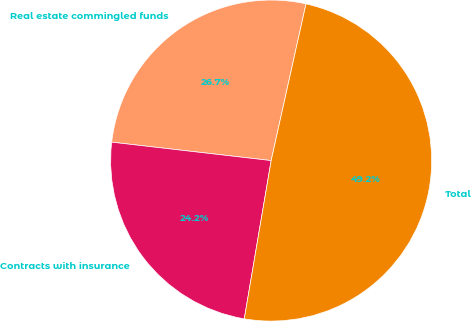<chart> <loc_0><loc_0><loc_500><loc_500><pie_chart><fcel>Real estate commingled funds<fcel>Contracts with insurance<fcel>Total<nl><fcel>26.65%<fcel>24.15%<fcel>49.19%<nl></chart> 